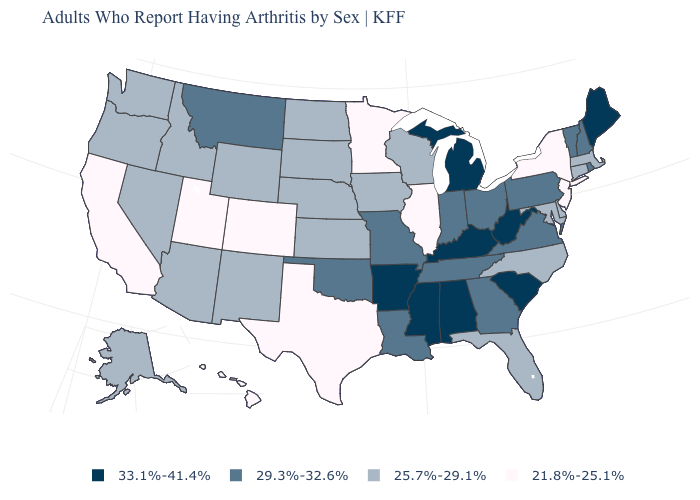What is the value of North Dakota?
Give a very brief answer. 25.7%-29.1%. What is the value of Vermont?
Keep it brief. 29.3%-32.6%. Name the states that have a value in the range 25.7%-29.1%?
Answer briefly. Alaska, Arizona, Connecticut, Delaware, Florida, Idaho, Iowa, Kansas, Maryland, Massachusetts, Nebraska, Nevada, New Mexico, North Carolina, North Dakota, Oregon, South Dakota, Washington, Wisconsin, Wyoming. Which states have the lowest value in the South?
Concise answer only. Texas. How many symbols are there in the legend?
Give a very brief answer. 4. Is the legend a continuous bar?
Short answer required. No. What is the value of Nebraska?
Concise answer only. 25.7%-29.1%. What is the highest value in the South ?
Keep it brief. 33.1%-41.4%. What is the lowest value in the USA?
Keep it brief. 21.8%-25.1%. What is the lowest value in states that border South Carolina?
Short answer required. 25.7%-29.1%. Name the states that have a value in the range 33.1%-41.4%?
Keep it brief. Alabama, Arkansas, Kentucky, Maine, Michigan, Mississippi, South Carolina, West Virginia. Name the states that have a value in the range 29.3%-32.6%?
Give a very brief answer. Georgia, Indiana, Louisiana, Missouri, Montana, New Hampshire, Ohio, Oklahoma, Pennsylvania, Rhode Island, Tennessee, Vermont, Virginia. Name the states that have a value in the range 25.7%-29.1%?
Answer briefly. Alaska, Arizona, Connecticut, Delaware, Florida, Idaho, Iowa, Kansas, Maryland, Massachusetts, Nebraska, Nevada, New Mexico, North Carolina, North Dakota, Oregon, South Dakota, Washington, Wisconsin, Wyoming. What is the value of Vermont?
Keep it brief. 29.3%-32.6%. Name the states that have a value in the range 33.1%-41.4%?
Concise answer only. Alabama, Arkansas, Kentucky, Maine, Michigan, Mississippi, South Carolina, West Virginia. 